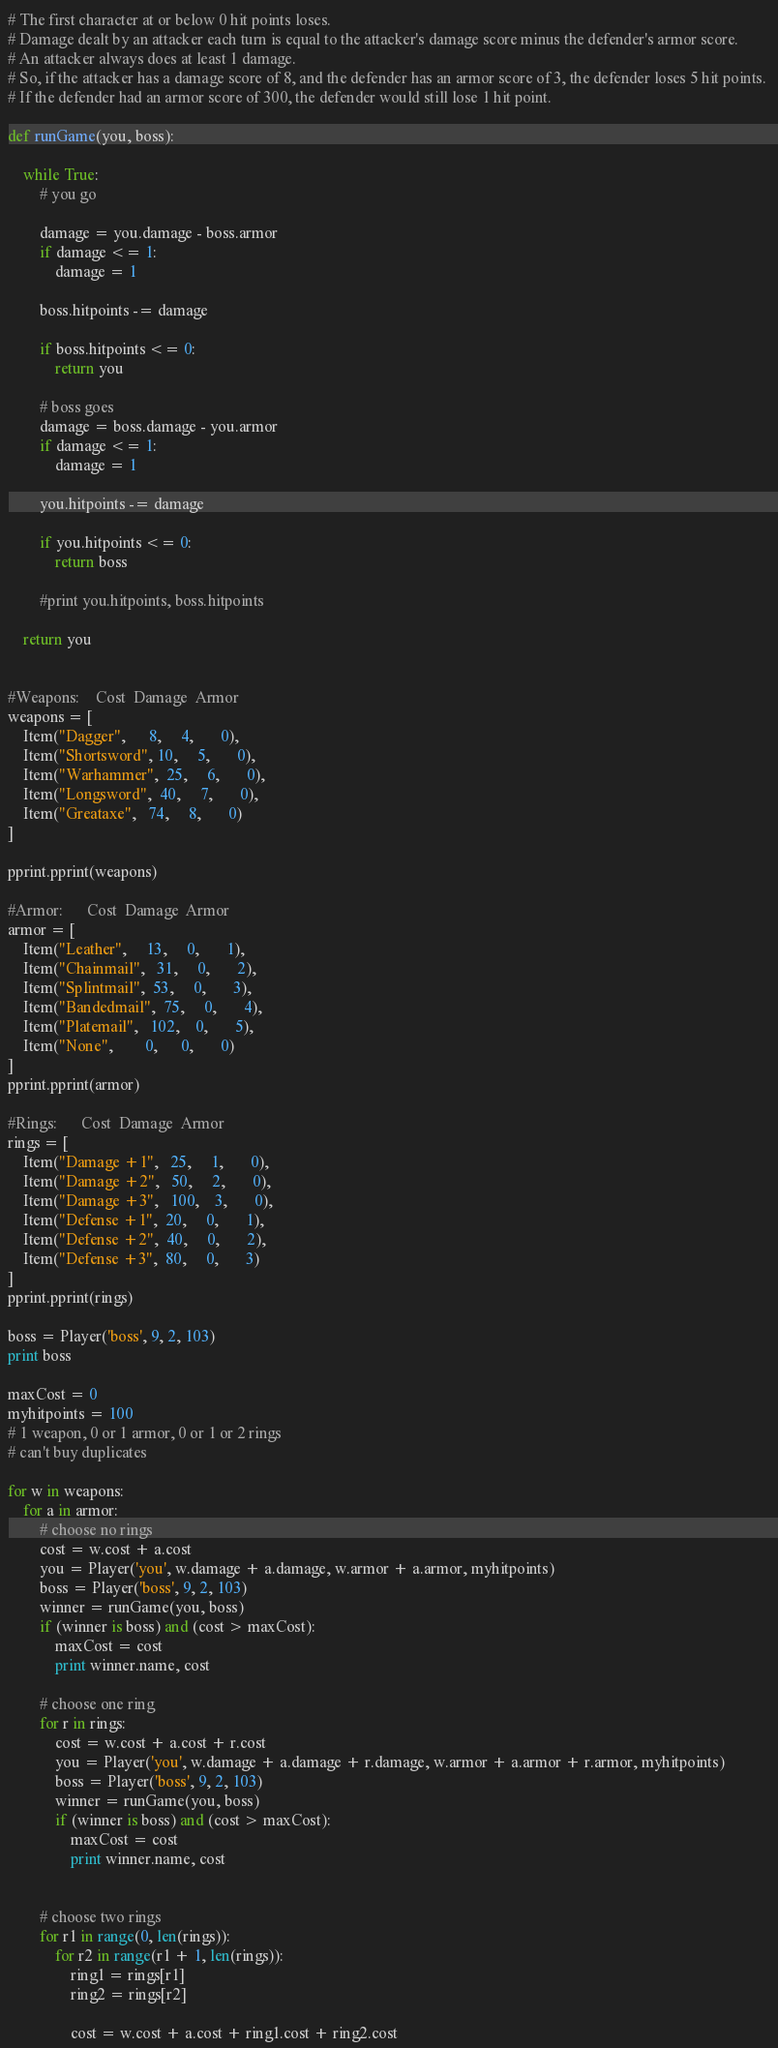<code> <loc_0><loc_0><loc_500><loc_500><_Python_># The first character at or below 0 hit points loses.
# Damage dealt by an attacker each turn is equal to the attacker's damage score minus the defender's armor score.
# An attacker always does at least 1 damage. 
# So, if the attacker has a damage score of 8, and the defender has an armor score of 3, the defender loses 5 hit points. 
# If the defender had an armor score of 300, the defender would still lose 1 hit point.

def runGame(you, boss):

    while True:
        # you go

        damage = you.damage - boss.armor
        if damage <= 1:
            damage = 1

        boss.hitpoints -= damage

        if boss.hitpoints <= 0:
            return you

        # boss goes
        damage = boss.damage - you.armor
        if damage <= 1:
            damage = 1

        you.hitpoints -= damage

        if you.hitpoints <= 0:
            return boss

        #print you.hitpoints, boss.hitpoints

    return you


#Weapons:    Cost  Damage  Armor
weapons = [
    Item("Dagger",      8,     4,       0),
    Item("Shortsword", 10,     5,       0),
    Item("Warhammer",  25,     6,       0),
    Item("Longsword",  40,     7,       0),
    Item("Greataxe",   74,     8,       0)
]

pprint.pprint(weapons)

#Armor:      Cost  Damage  Armor
armor = [
    Item("Leather",     13,     0,       1),
    Item("Chainmail",   31,     0,       2),
    Item("Splintmail",  53,     0,       3),
    Item("Bandedmail",  75,     0,       4),
    Item("Platemail",   102,    0,       5),
    Item("None",        0,      0,       0)
]
pprint.pprint(armor)

#Rings:      Cost  Damage  Armor
rings = [
    Item("Damage +1",   25,     1,       0),
    Item("Damage +2",   50,     2,       0),
    Item("Damage +3",   100,    3,       0),
    Item("Defense +1",  20,     0,       1),
    Item("Defense +2",  40,     0,       2),
    Item("Defense +3",  80,     0,       3)
]
pprint.pprint(rings)

boss = Player('boss', 9, 2, 103)
print boss

maxCost = 0
myhitpoints = 100
# 1 weapon, 0 or 1 armor, 0 or 1 or 2 rings
# can't buy duplicates

for w in weapons:
    for a in armor:
        # choose no rings
        cost = w.cost + a.cost
        you = Player('you', w.damage + a.damage, w.armor + a.armor, myhitpoints)
        boss = Player('boss', 9, 2, 103)
        winner = runGame(you, boss)
        if (winner is boss) and (cost > maxCost):
            maxCost = cost
            print winner.name, cost

        # choose one ring
        for r in rings:
            cost = w.cost + a.cost + r.cost
            you = Player('you', w.damage + a.damage + r.damage, w.armor + a.armor + r.armor, myhitpoints)
            boss = Player('boss', 9, 2, 103)
            winner = runGame(you, boss)
            if (winner is boss) and (cost > maxCost):
                maxCost = cost
                print winner.name, cost


        # choose two rings
        for r1 in range(0, len(rings)):
            for r2 in range(r1 + 1, len(rings)):
                ring1 = rings[r1]
                ring2 = rings[r2]

                cost = w.cost + a.cost + ring1.cost + ring2.cost</code> 